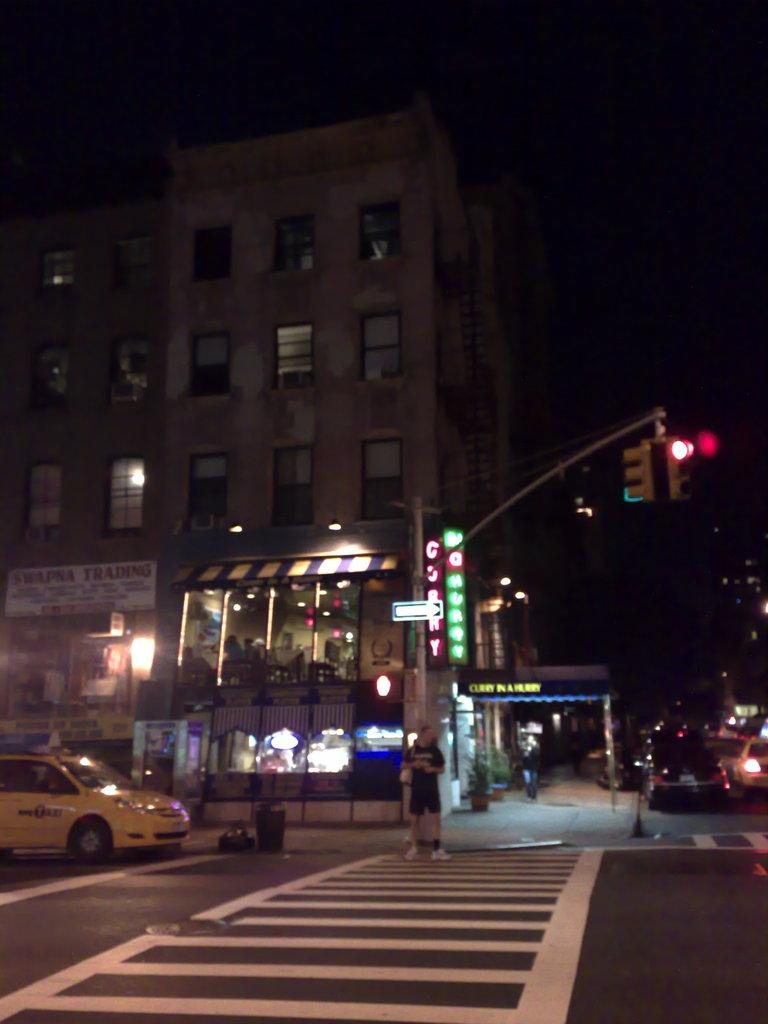What time of day is depicted in the image? The image depicts a night view of a place. What can be seen on the road in the image? There are vehicles on the road in the image. What is present on the road to regulate traffic? There is a traffic signal pole on the road. What features can be observed on the buildings in the image? There are buildings with lights and windows visible in the image. What type of airport can be seen in the image? There is no airport present in the image; it depicts a night view of a place with vehicles, a traffic signal pole, and buildings with lights and windows. What is the brake system like for the vehicles in the image? The image does not provide information about the brake systems of the vehicles; it only shows their presence on the road. 